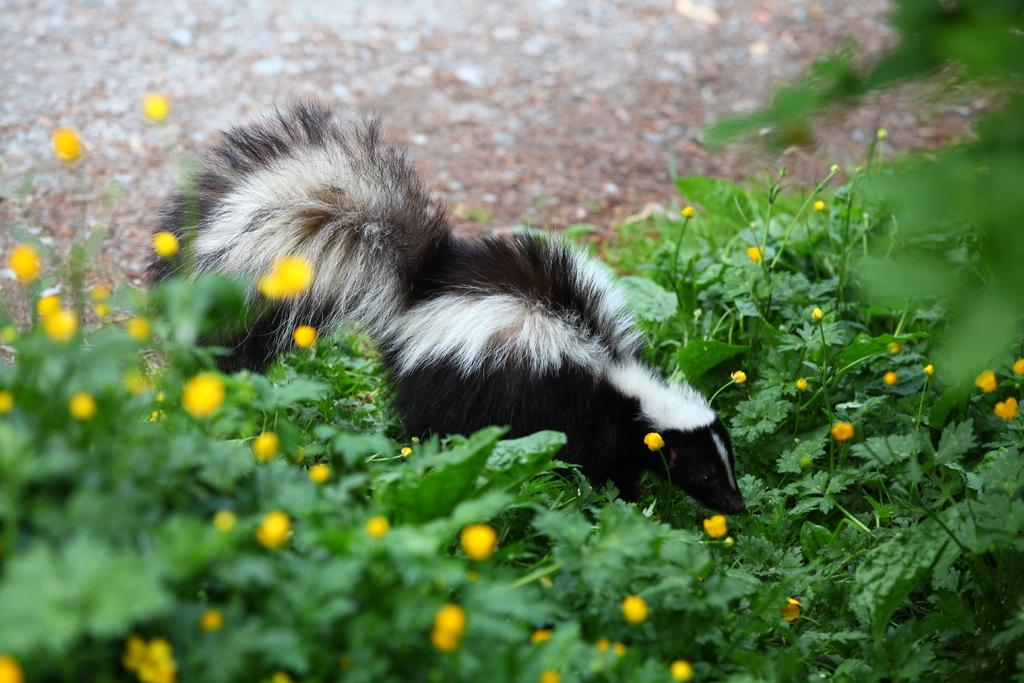What types of vegetation are at the bottom of the image? There are flowers and plants at the bottom of the image. What is the main subject in the middle of the image? There is an animal in the middle of the image. What color scheme is used for the animal? The animal is in black and white color. How many feathers can be seen on the monkey in the image? There is no monkey present in the image, and therefore no feathers can be observed. What is the fifth object in the image? The provided facts do not mention a fifth object, so it cannot be determined from the information given. 